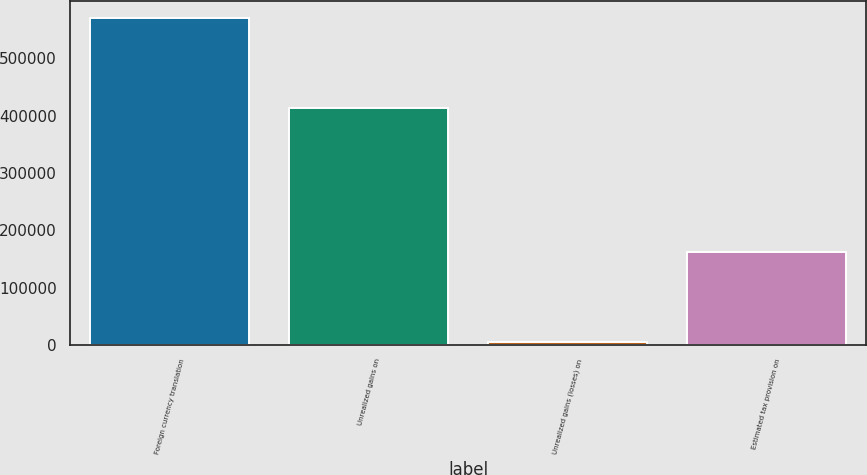Convert chart. <chart><loc_0><loc_0><loc_500><loc_500><bar_chart><fcel>Foreign currency translation<fcel>Unrealized gains on<fcel>Unrealized gains (losses) on<fcel>Estimated tax provision on<nl><fcel>570440<fcel>413754<fcel>4821<fcel>161269<nl></chart> 